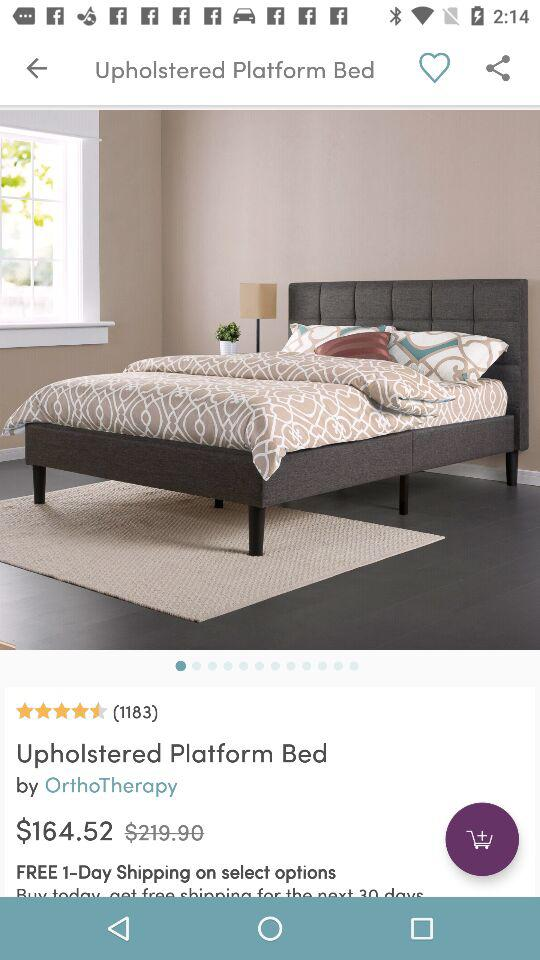How much more is the original price than the sale price?
Answer the question using a single word or phrase. $55.38 